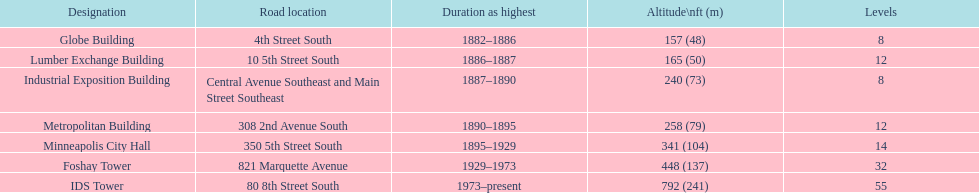What was the first building named as the tallest? Globe Building. 